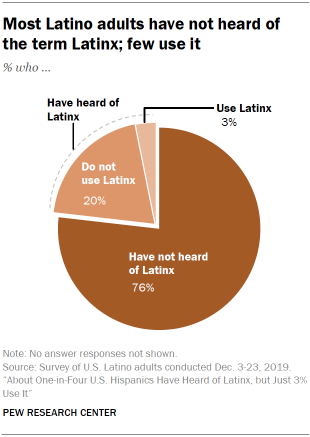Outline some significant characteristics in this image. The sum of the two smallest slices is 0.23... The smallest slice of this graph is represented by the Latinx culture, which is characterized by its unique blend of influences from various Latin American countries. 